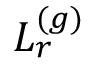Convert formula to latex. <formula><loc_0><loc_0><loc_500><loc_500>L _ { r } ^ { ( g ) }</formula> 